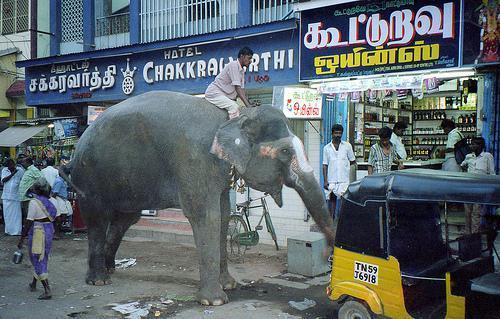How many elephants are in this photo?
Give a very brief answer. 1. 